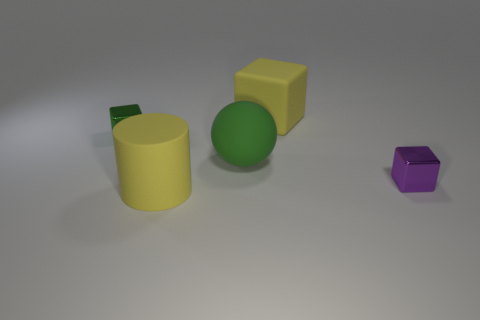Are there fewer green metallic objects than matte things?
Ensure brevity in your answer.  Yes. What is the material of the yellow thing left of the large green matte sphere?
Give a very brief answer. Rubber. What is the material of the purple object that is the same size as the green cube?
Provide a succinct answer. Metal. The large yellow object right of the yellow thing that is in front of the shiny object that is on the left side of the tiny purple metallic block is made of what material?
Your response must be concise. Rubber. Do the shiny thing right of the green cube and the sphere have the same size?
Provide a short and direct response. No. Are there more small blocks than rubber things?
Your answer should be very brief. No. How many big objects are cyan matte cubes or green metal blocks?
Keep it short and to the point. 0. What number of other objects are there of the same color as the big block?
Offer a terse response. 1. What number of purple cubes are the same material as the cylinder?
Your response must be concise. 0. Do the small block that is behind the small purple block and the matte ball have the same color?
Give a very brief answer. Yes. 